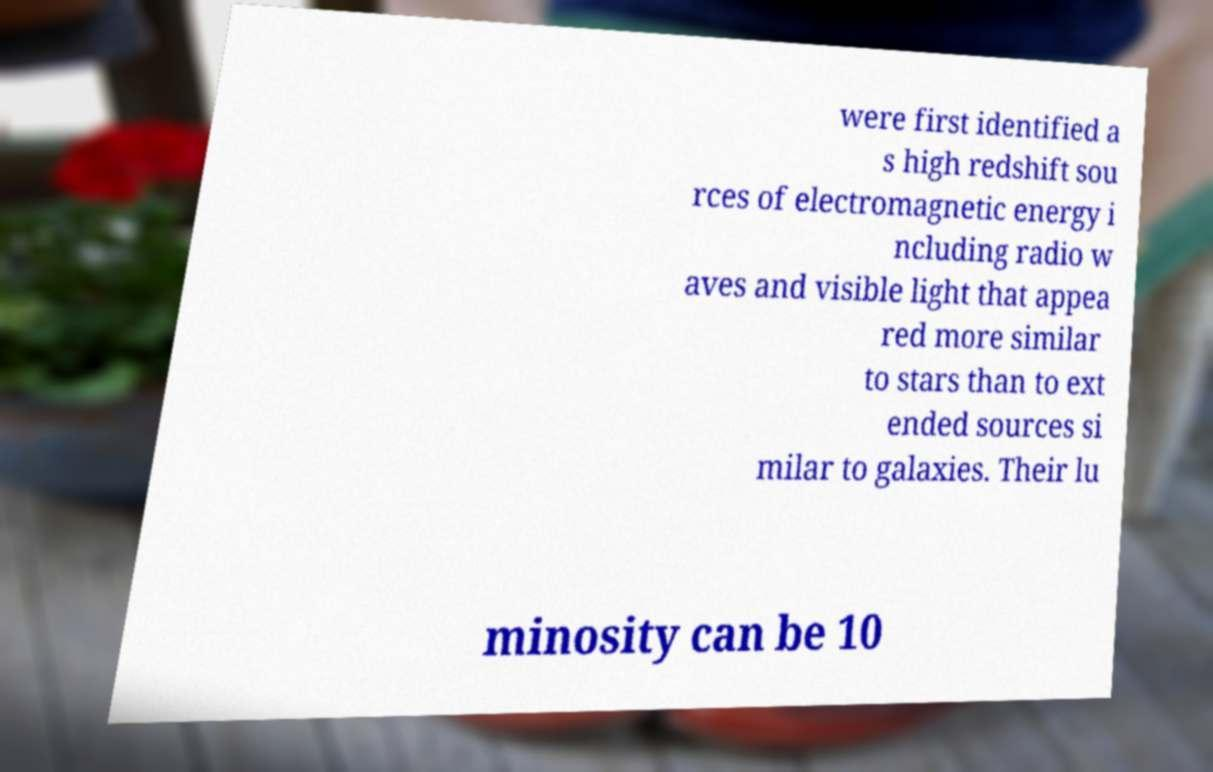Could you extract and type out the text from this image? were first identified a s high redshift sou rces of electromagnetic energy i ncluding radio w aves and visible light that appea red more similar to stars than to ext ended sources si milar to galaxies. Their lu minosity can be 10 